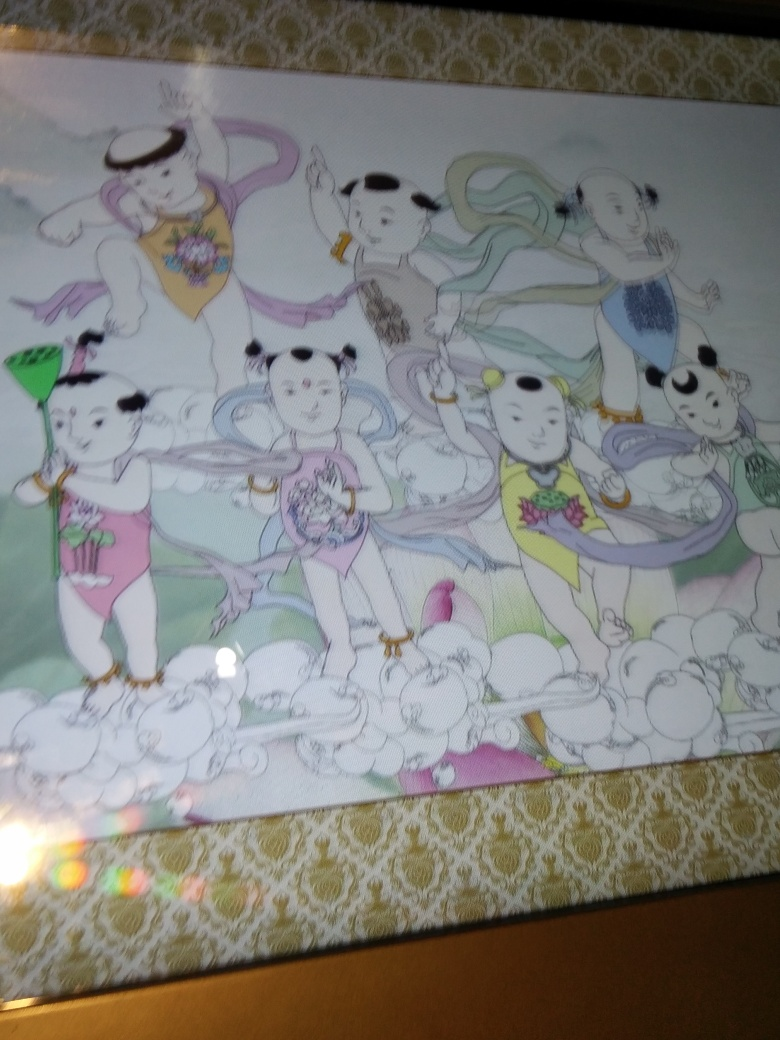What do the colors and style of this image suggest about its origin? The use of soft pastel colors and the traditional costumes on the characters hint at an East Asian influence, perhaps Chinese or Japanese. The style is reminiscent of classical Asian art, yet it's been given a modern twist with the anthropomorphic panda characters, merging traditional and contemporary elements. 